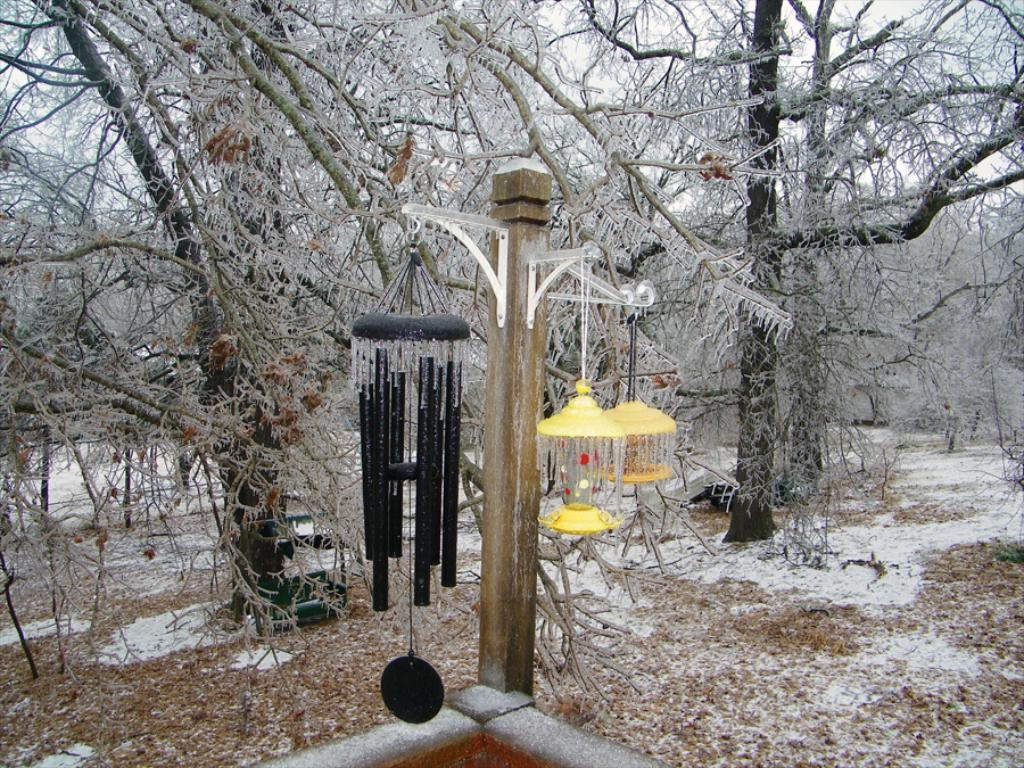What type of lighting is present in the image? There are lanterns in the image. What structure can be seen in the image? There is a pole in the image. What decorative element is featured in the image? There is a decorative object in the image. What can be seen in the background of the image? The background of the image includes trees, snow, and dry leaves. What color is the sock on the pole in the image? There is no sock present in the image; it features lanterns, a pole, a decorative object, and a background with trees, snow, and dry leaves. Can you tell me how many people are driving in the image? There is no driving activity depicted in the image. 